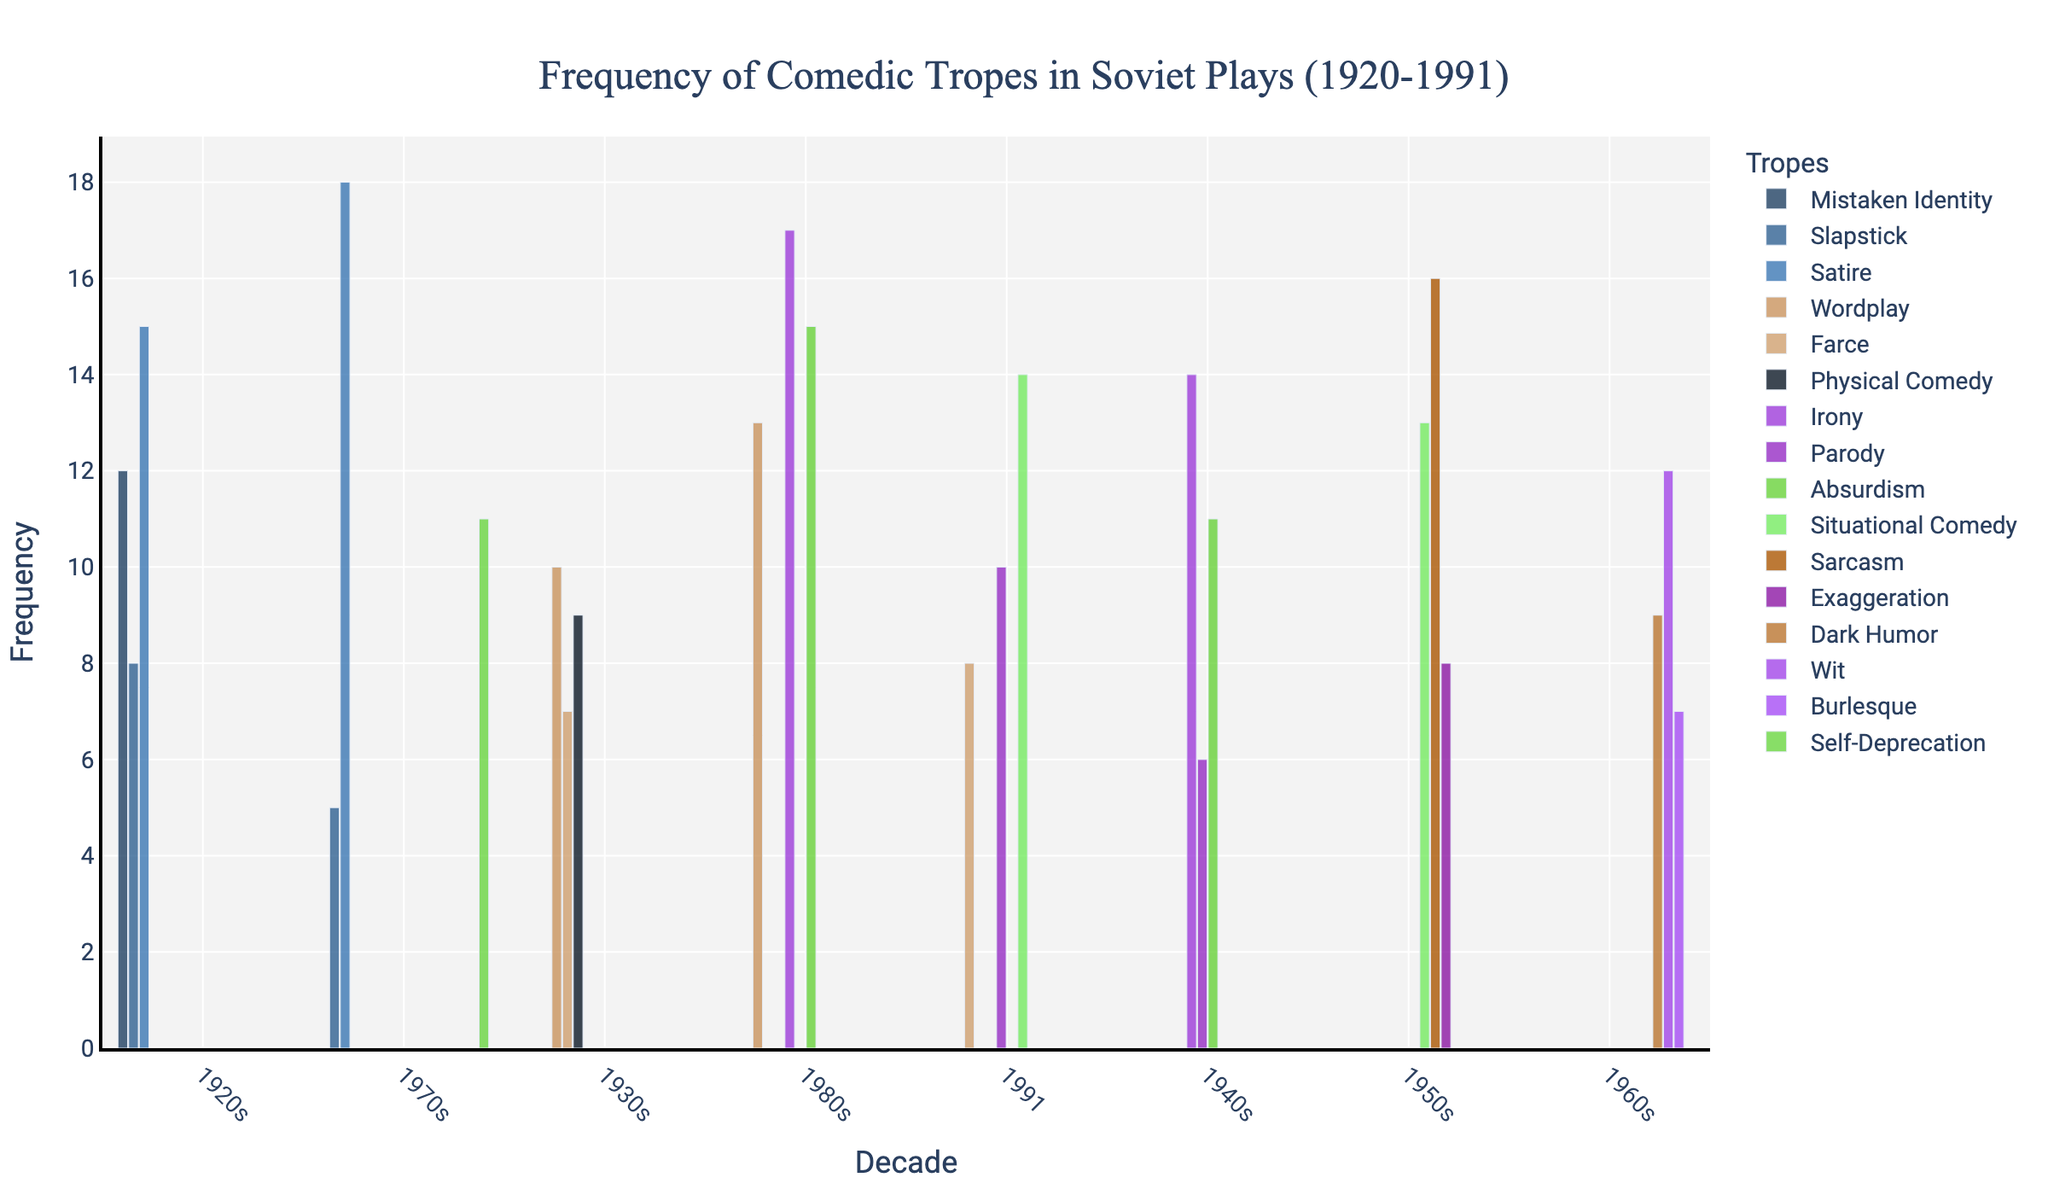What is the most frequently occurring comedic trope in the 1950s? To find the most frequent trope in the 1950s, look at the heights of the bars for the 1950s and compare their values. The tallest bar represents "Sarcasm" with a frequency of 16.
Answer: Sarcasm Which decade features the highest occurrence of "Satire"? Consider the bars corresponding to "Satire" across all decades. The bar in the 1970s is the highest with a frequency of 18, compared to 15 in the 1920s.
Answer: 1970s What is the total frequency of "Irony" across all decades? Sum the frequencies of "Irony" across the decades: 14 in the 1940s and 17 in the 1980s. 14 + 17 = 31.
Answer: 31 Which decade has the most diverse set of comedic tropes (different types)? To determine diversity, count the unique comedic tropes per decade. Each column (decade) on the x-axis has different numbers of bars. The 1920s, 1930s, 1940s, and 1960s each host three unique tropes. The 1950s, 1970s, and 1980s each have three unique tropes. 1991 has three tropes too.
Answer: All decades have five unique tropes Compare the frequency of "Absurdism" in the 1940s and the 1980s. Which decade has higher frequency and by how much? Look at the heights of the bars for "Absurdism" for both decades. In the 1940s, the frequency is 11, while in the 1980s, it is 15. The difference is 15 - 11 = 4.
Answer: 1980s, by 4 What is the average frequency of comedic tropes in the 1991 data point? Sum the frequencies of all tropes in 1991: Parody (10), Farce (8), Situational Comedy (14). Then, divide by the number of tropes: (10 + 8 + 14) / 3 = 32 / 3 ≈ 10.67.
Answer: 10.67 How many times does "Wordplay" appear in Soviet plays from the 1920s to the 1980s? Sum the occurrences of "Wordplay" across all specific decades: 10 in the 1930s and 13 in the 1980s. 10 + 13 = 23.
Answer: 23 Which comedic trope shows the highest increase in frequency from one decade to the next? Analyze the differences in frequency for each trope between consecutive decades. "Irony" increases from 14 (1940s) to 17 (1980s), an increase of 3. However, "Satire" increases from 15 (1920s) to 18 (1970s), an increase of 3.
Answer: Satire, by 3 